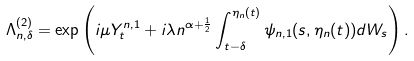<formula> <loc_0><loc_0><loc_500><loc_500>\Lambda ^ { ( 2 ) } _ { n , \delta } = \exp \left ( i \mu Y ^ { n , 1 } _ { t } + i \lambda n ^ { \alpha + \frac { 1 } { 2 } } \int _ { t - \delta } ^ { \eta _ { n } ( t ) } \psi _ { n , 1 } ( s , \eta _ { n } ( t ) ) d W _ { s } \right ) .</formula> 